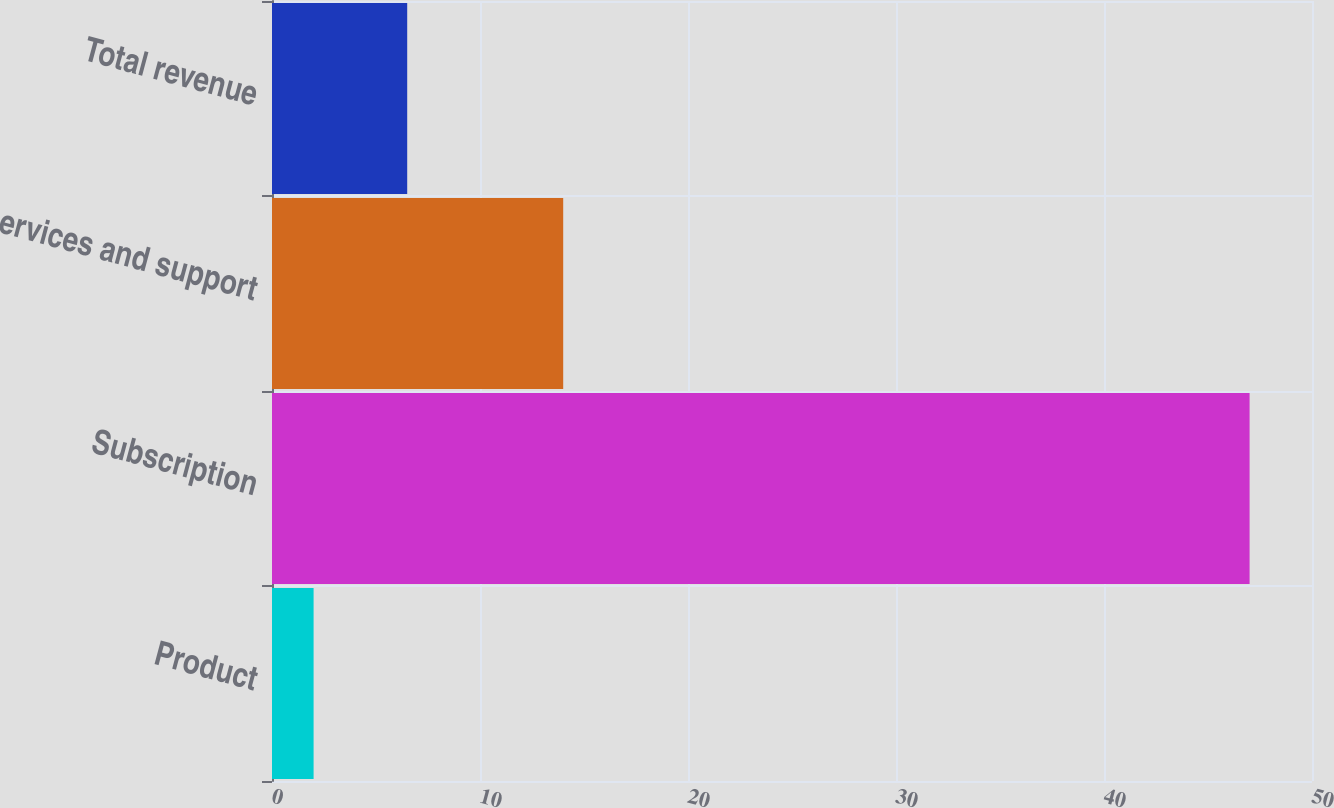Convert chart to OTSL. <chart><loc_0><loc_0><loc_500><loc_500><bar_chart><fcel>Product<fcel>Subscription<fcel>Services and support<fcel>Total revenue<nl><fcel>2<fcel>47<fcel>14<fcel>6.5<nl></chart> 